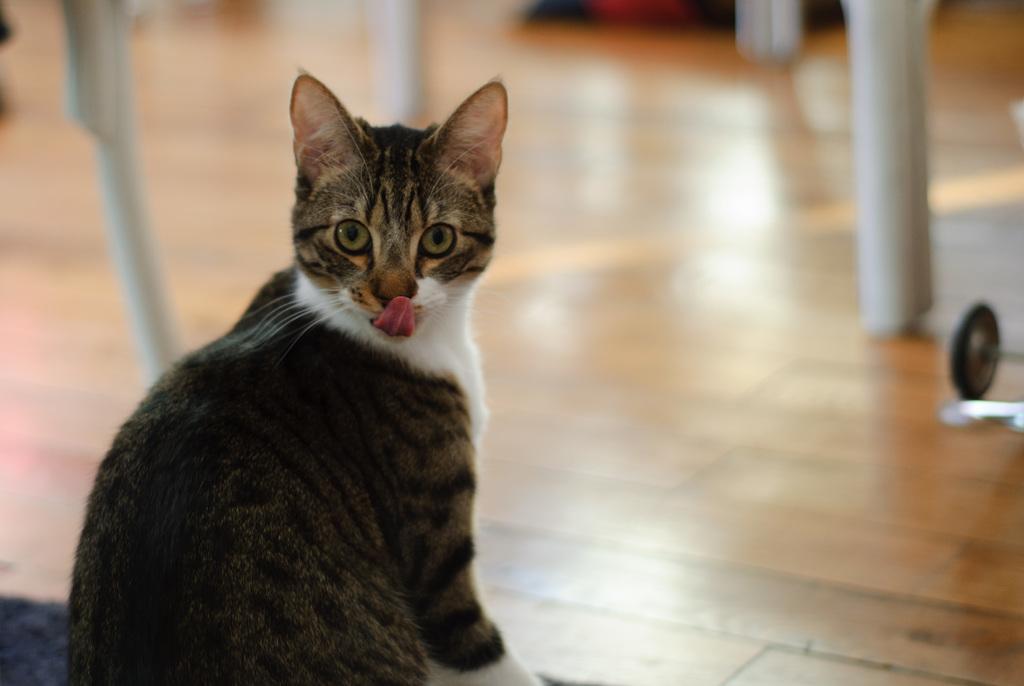Describe this image in one or two sentences. In the image we can see there is a cat sitting on the floor and she kept her tongue out. Behind the background is blurred. 